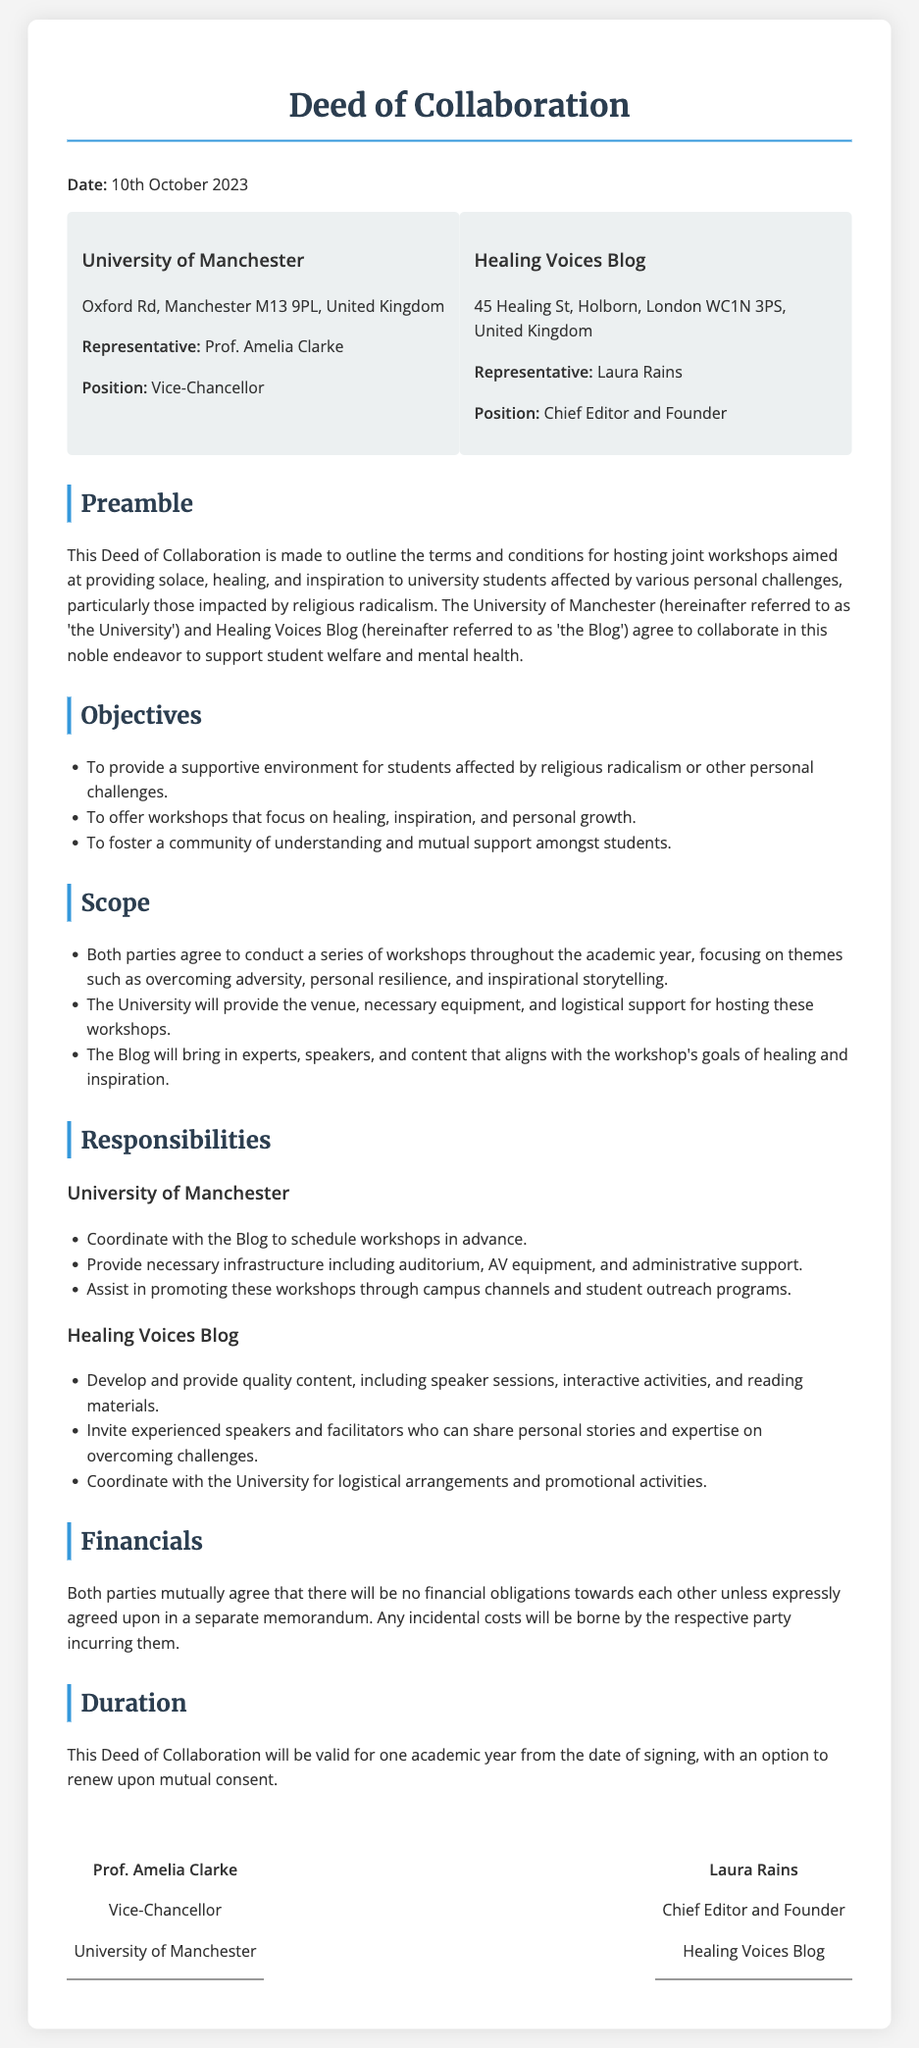What is the date of the Deed of Collaboration? The date is mentioned at the beginning of the document as the date it was signed.
Answer: 10th October 2023 Who is the representative of the University of Manchester? The representative's name is specified under the section outlining the parties involved.
Answer: Prof. Amelia Clarke What is the primary theme of the joint workshops? The objectives section states the focus of the workshops in relation to student support.
Answer: Healing and inspiration What is the duration of this Deed of Collaboration? The document specifies how long the collaboration will be valid.
Answer: One academic year Who is the Chief Editor of the Healing Voices Blog? The position of the representative of the Blog is clearly stated in the document.
Answer: Laura Rains What financial obligations do the parties agree upon? The financial section contains the details regarding financial responsibilities.
Answer: No financial obligations What will the University provide for the workshops? The responsibilities section outlines specific contributions from the University.
Answer: Venue, equipment, and logistical support What will the Blog provide for the workshops? The responsibilities section also details what the Blog agrees to offer during the collaboration.
Answer: Quality content, speakers, and activities 